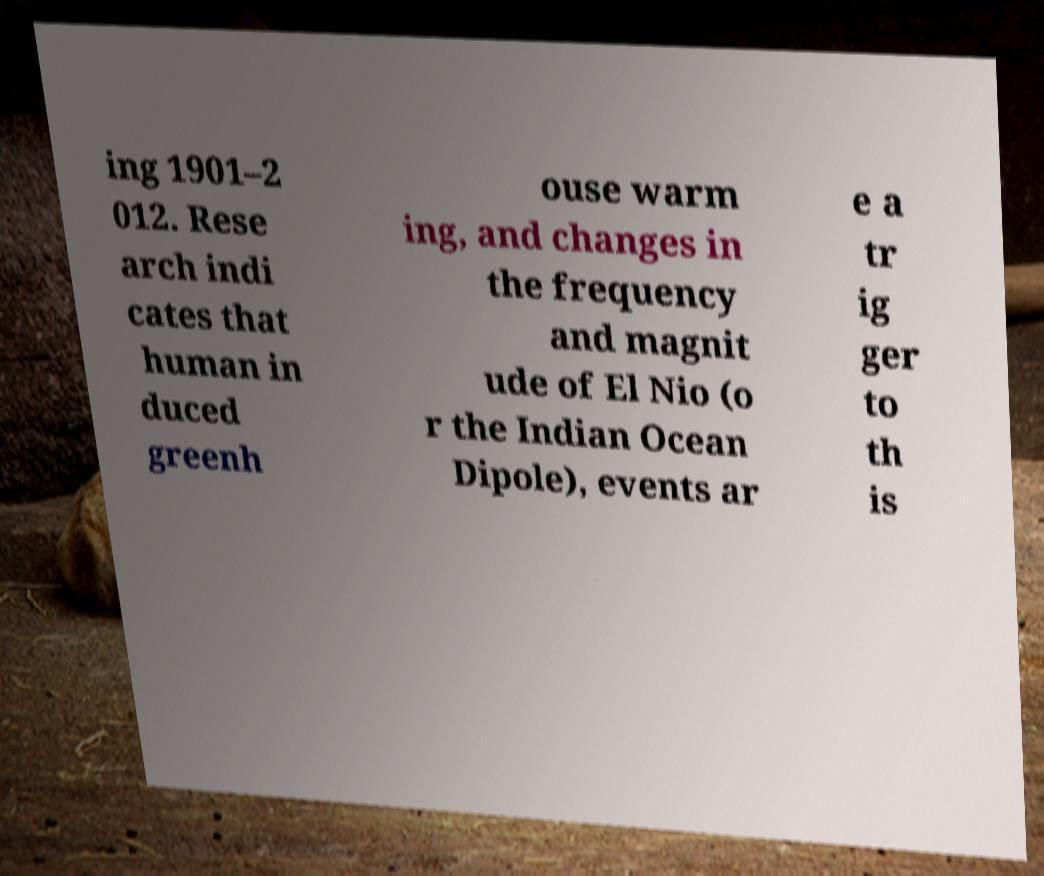Could you assist in decoding the text presented in this image and type it out clearly? ing 1901–2 012. Rese arch indi cates that human in duced greenh ouse warm ing, and changes in the frequency and magnit ude of El Nio (o r the Indian Ocean Dipole), events ar e a tr ig ger to th is 